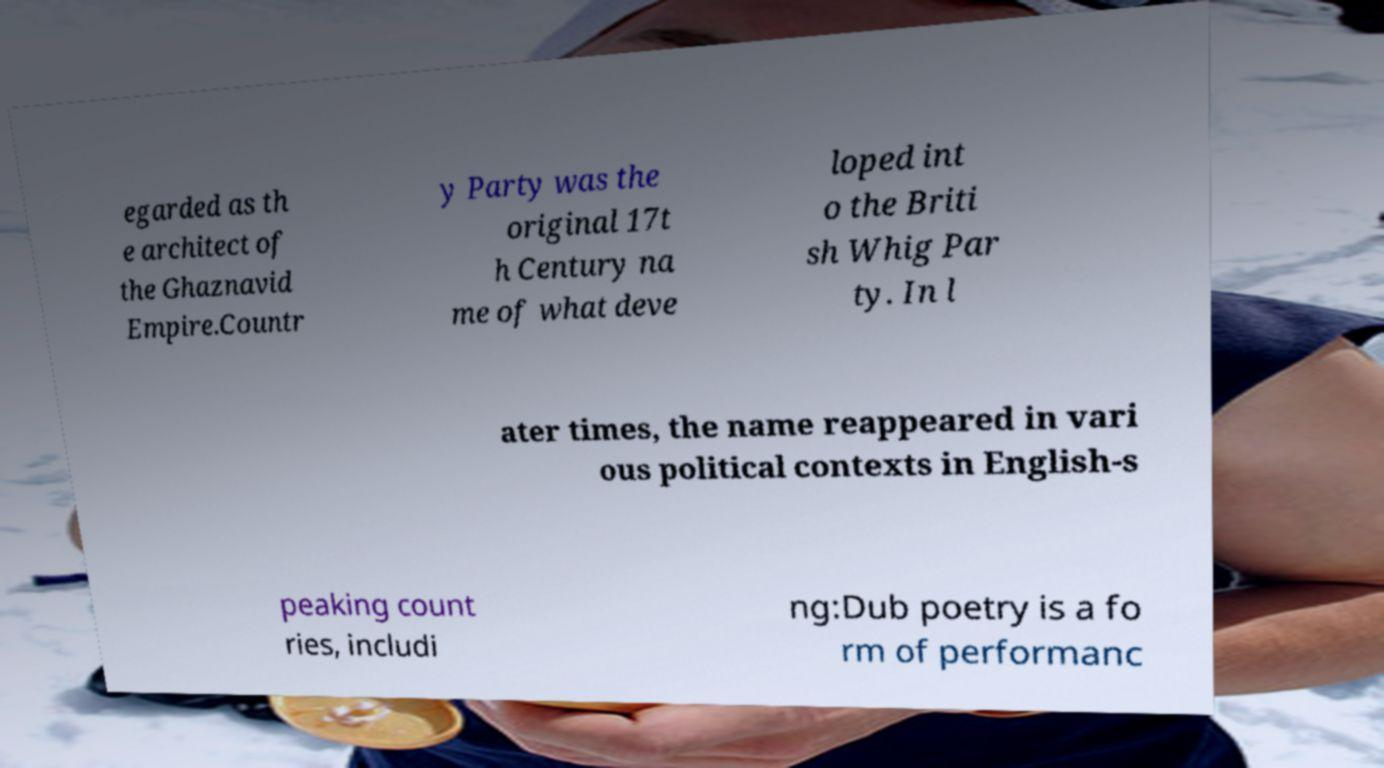Could you assist in decoding the text presented in this image and type it out clearly? egarded as th e architect of the Ghaznavid Empire.Countr y Party was the original 17t h Century na me of what deve loped int o the Briti sh Whig Par ty. In l ater times, the name reappeared in vari ous political contexts in English-s peaking count ries, includi ng:Dub poetry is a fo rm of performanc 